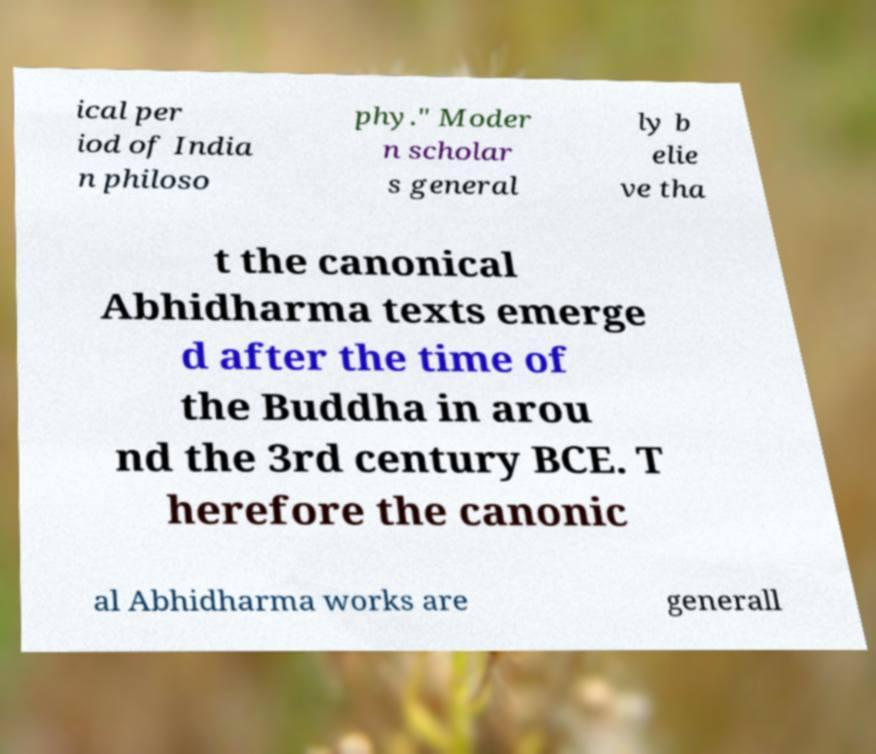For documentation purposes, I need the text within this image transcribed. Could you provide that? ical per iod of India n philoso phy." Moder n scholar s general ly b elie ve tha t the canonical Abhidharma texts emerge d after the time of the Buddha in arou nd the 3rd century BCE. T herefore the canonic al Abhidharma works are generall 